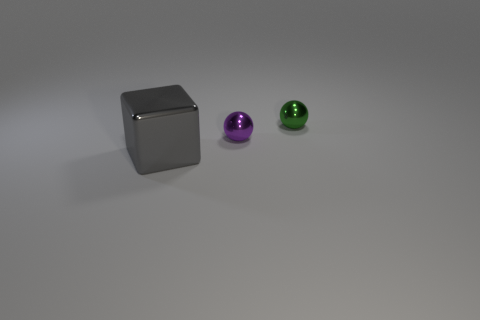Is the size of the gray cube the same as the metal sphere behind the tiny purple sphere?
Provide a short and direct response. No. Is there a green thing that has the same shape as the purple object?
Offer a very short reply. Yes. What shape is the metallic thing that is behind the metallic cube and to the left of the small green shiny object?
Ensure brevity in your answer.  Sphere. What number of tiny blue cylinders have the same material as the small green sphere?
Give a very brief answer. 0. Is the number of small purple shiny things behind the green metal ball less than the number of small purple rubber balls?
Provide a short and direct response. No. Is there a gray thing that is on the left side of the sphere that is on the left side of the small green metal sphere?
Provide a short and direct response. Yes. Is there anything else that has the same shape as the big gray metal object?
Your response must be concise. No. Does the purple object have the same size as the green metal sphere?
Your answer should be compact. Yes. Are there an equal number of large gray shiny things right of the large cube and green metal spheres?
Keep it short and to the point. No. Is there anything else that is the same size as the shiny cube?
Offer a very short reply. No. 